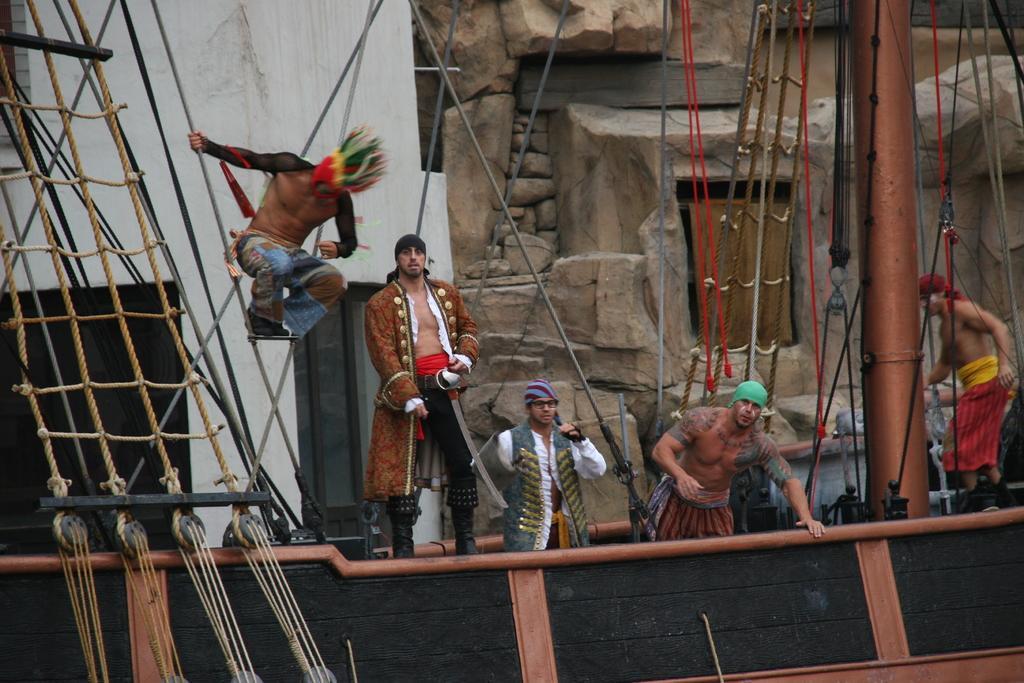Could you give a brief overview of what you see in this image? In this image there are a few men standing. To the left there is a man jumping in the air. In the foreground there are ropes, wires and a pole. It seems to be a ship. Behind them there are walls. 